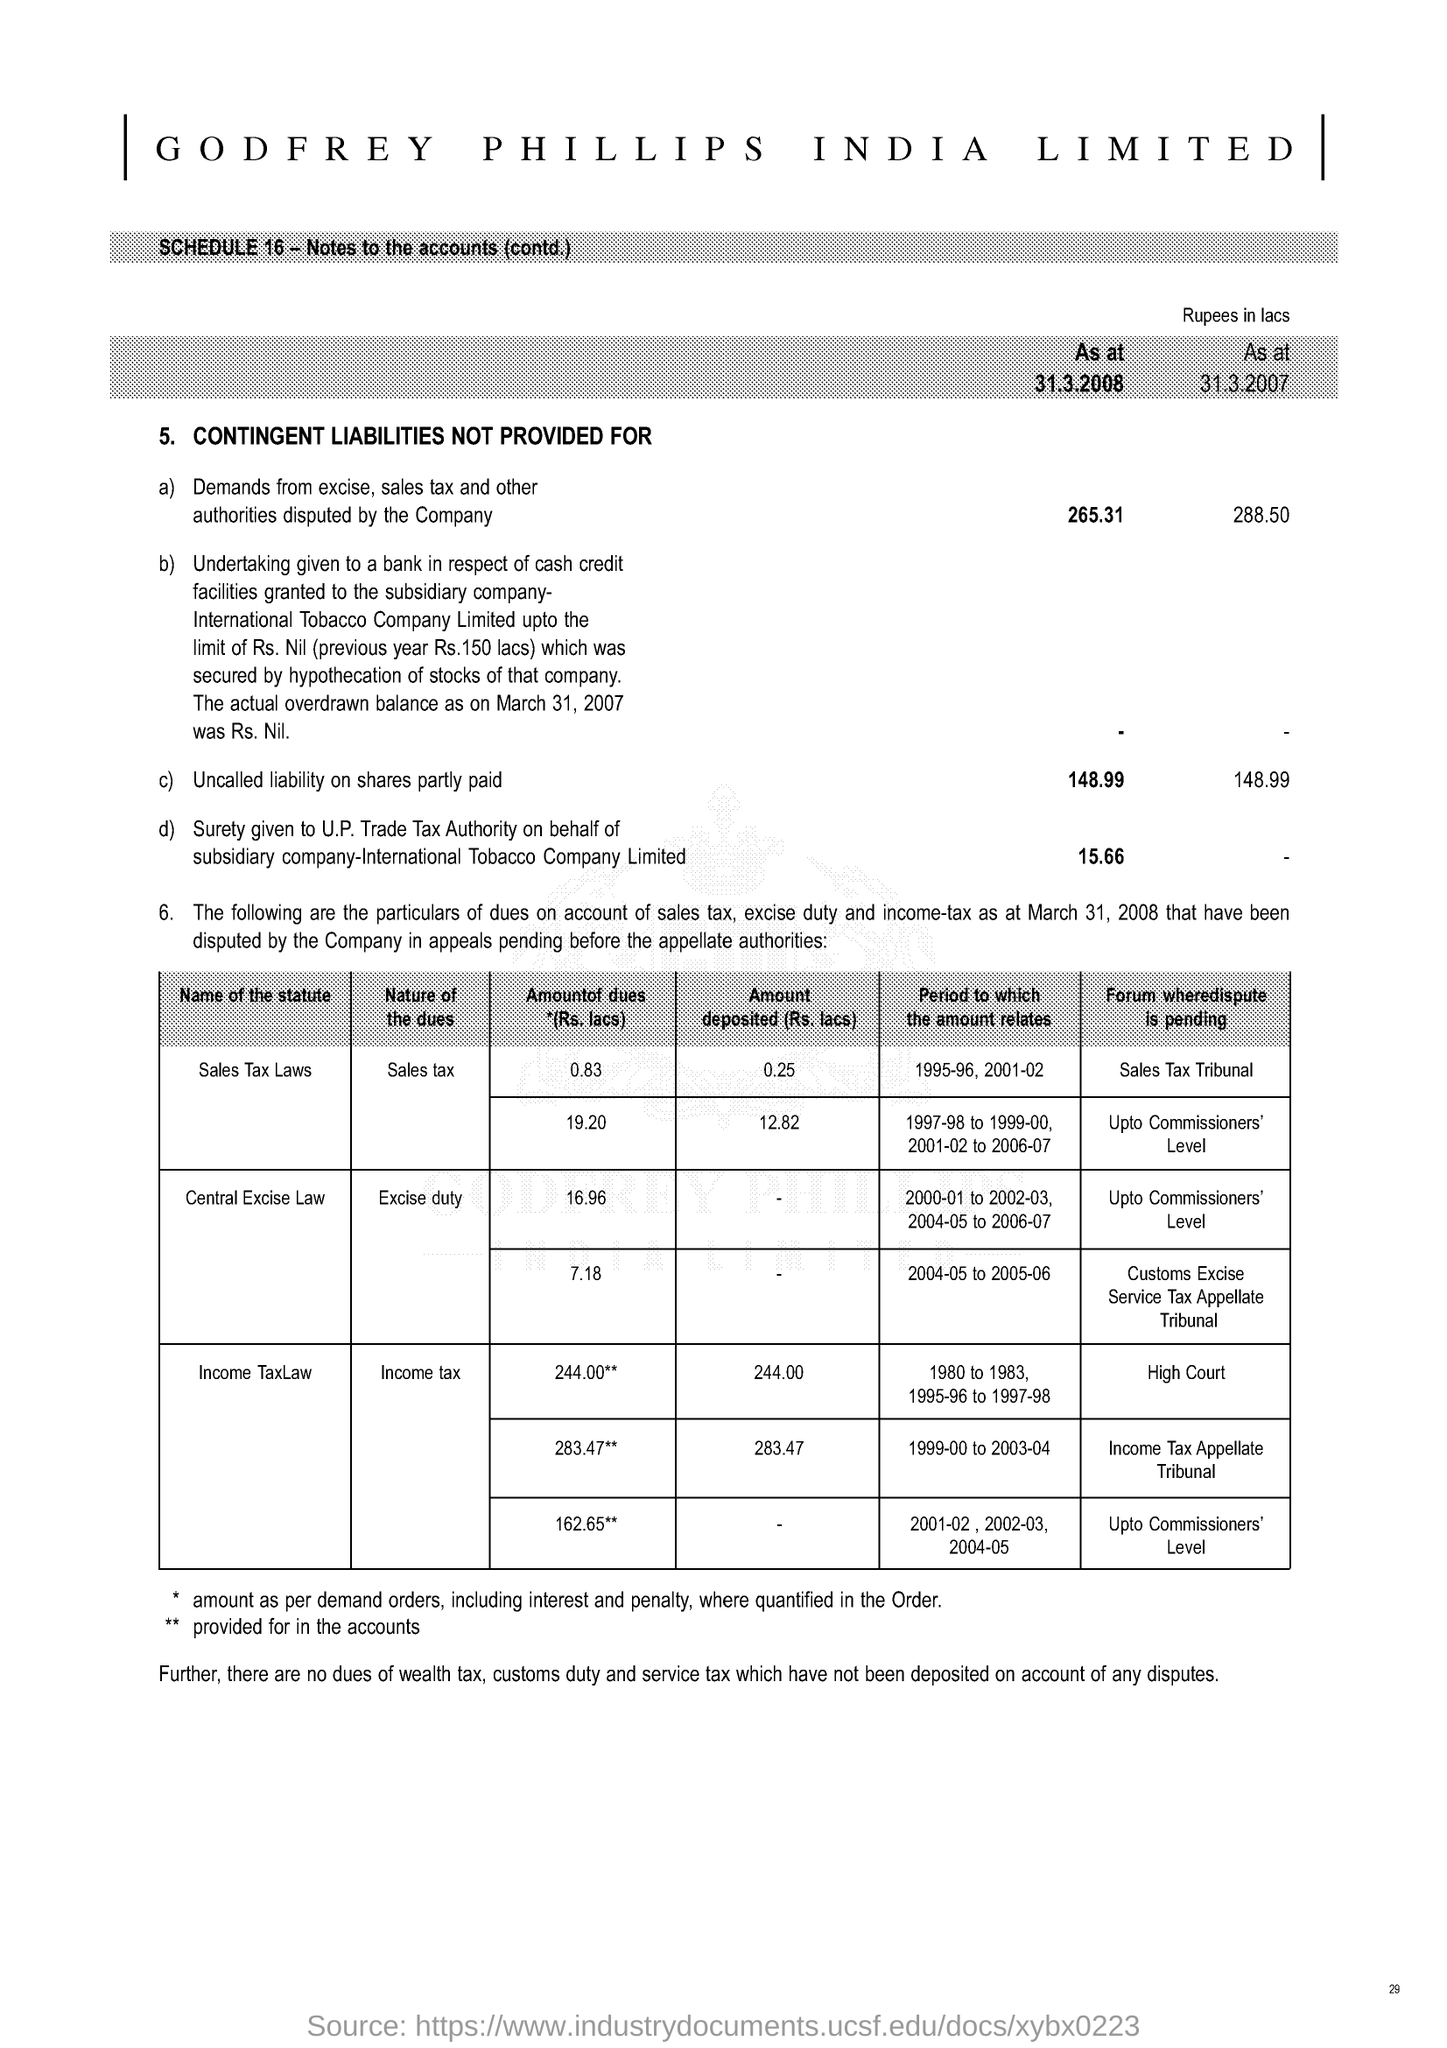Point out several critical features in this image. The question is asking for the amount of uncalled liability on partially paid shares as of March 31, 2007. 